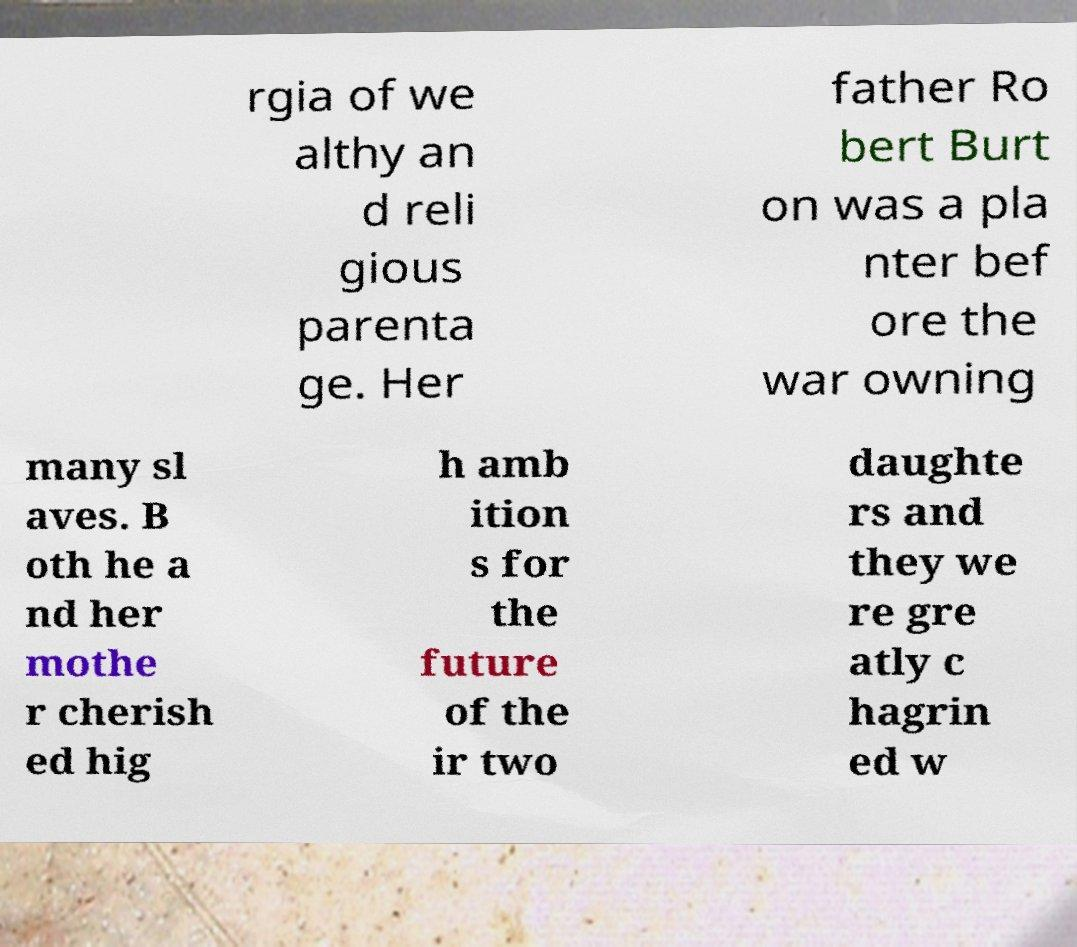Could you extract and type out the text from this image? rgia of we althy an d reli gious parenta ge. Her father Ro bert Burt on was a pla nter bef ore the war owning many sl aves. B oth he a nd her mothe r cherish ed hig h amb ition s for the future of the ir two daughte rs and they we re gre atly c hagrin ed w 